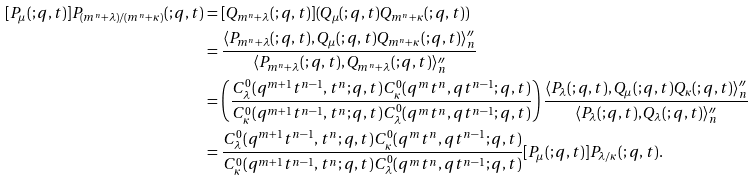Convert formula to latex. <formula><loc_0><loc_0><loc_500><loc_500>[ P _ { \mu } ( ; q , t ) ] P _ { ( m ^ { n } + \lambda ) / ( m ^ { n } + \kappa ) } ( ; q , t ) & = [ Q _ { m ^ { n } + \lambda } ( ; q , t ) ] ( Q _ { \mu } ( ; q , t ) Q _ { m ^ { n } + \kappa } ( ; q , t ) ) \\ & = \frac { \langle P _ { m ^ { n } + \lambda } ( ; q , t ) , Q _ { \mu } ( ; q , t ) Q _ { m ^ { n } + \kappa } ( ; q , t ) \rangle ^ { \prime \prime } _ { n } } { \langle P _ { m ^ { n } + \lambda } ( ; q , t ) , Q _ { m ^ { n } + \lambda } ( ; q , t ) \rangle ^ { \prime \prime } _ { n } } \\ & = \left ( \frac { C ^ { 0 } _ { \lambda } ( q ^ { m + 1 } t ^ { n - 1 } , t ^ { n } ; q , t ) C ^ { 0 } _ { \kappa } ( q ^ { m } t ^ { n } , q t ^ { n - 1 } ; q , t ) } { C ^ { 0 } _ { \kappa } ( q ^ { m + 1 } t ^ { n - 1 } , t ^ { n } ; q , t ) C ^ { 0 } _ { \lambda } ( q ^ { m } t ^ { n } , q t ^ { n - 1 } ; q , t ) } \right ) \frac { \langle P _ { \lambda } ( ; q , t ) , Q _ { \mu } ( ; q , t ) Q _ { \kappa } ( ; q , t ) \rangle ^ { \prime \prime } _ { n } } { \langle P _ { \lambda } ( ; q , t ) , Q _ { \lambda } ( ; q , t ) \rangle ^ { \prime \prime } _ { n } } \\ & = \frac { C ^ { 0 } _ { \lambda } ( q ^ { m + 1 } t ^ { n - 1 } , t ^ { n } ; q , t ) C ^ { 0 } _ { \kappa } ( q ^ { m } t ^ { n } , q t ^ { n - 1 } ; q , t ) } { C ^ { 0 } _ { \kappa } ( q ^ { m + 1 } t ^ { n - 1 } , t ^ { n } ; q , t ) C ^ { 0 } _ { \lambda } ( q ^ { m } t ^ { n } , q t ^ { n - 1 } ; q , t ) } [ P _ { \mu } ( ; q , t ) ] P _ { \lambda / \kappa } ( ; q , t ) .</formula> 